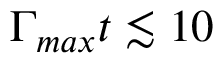Convert formula to latex. <formula><loc_0><loc_0><loc_500><loc_500>\Gamma _ { \max } t \lesssim 1 0</formula> 